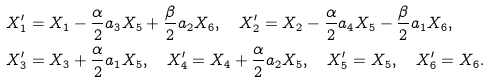<formula> <loc_0><loc_0><loc_500><loc_500>& X _ { 1 } ^ { \prime } = X _ { 1 } - \frac { \alpha } { 2 } a _ { 3 } X _ { 5 } + \frac { \beta } { 2 } a _ { 2 } X _ { 6 } , \quad X _ { 2 } ^ { \prime } = X _ { 2 } - \frac { \alpha } { 2 } a _ { 4 } X _ { 5 } - \frac { \beta } { 2 } a _ { 1 } X _ { 6 } , \\ & X _ { 3 } ^ { \prime } = X _ { 3 } + \frac { \alpha } { 2 } a _ { 1 } X _ { 5 } , \quad X _ { 4 } ^ { \prime } = X _ { 4 } + \frac { \alpha } { 2 } a _ { 2 } X _ { 5 } , \quad X _ { 5 } ^ { \prime } = X _ { 5 } , \quad X _ { 6 } ^ { \prime } = X _ { 6 } .</formula> 